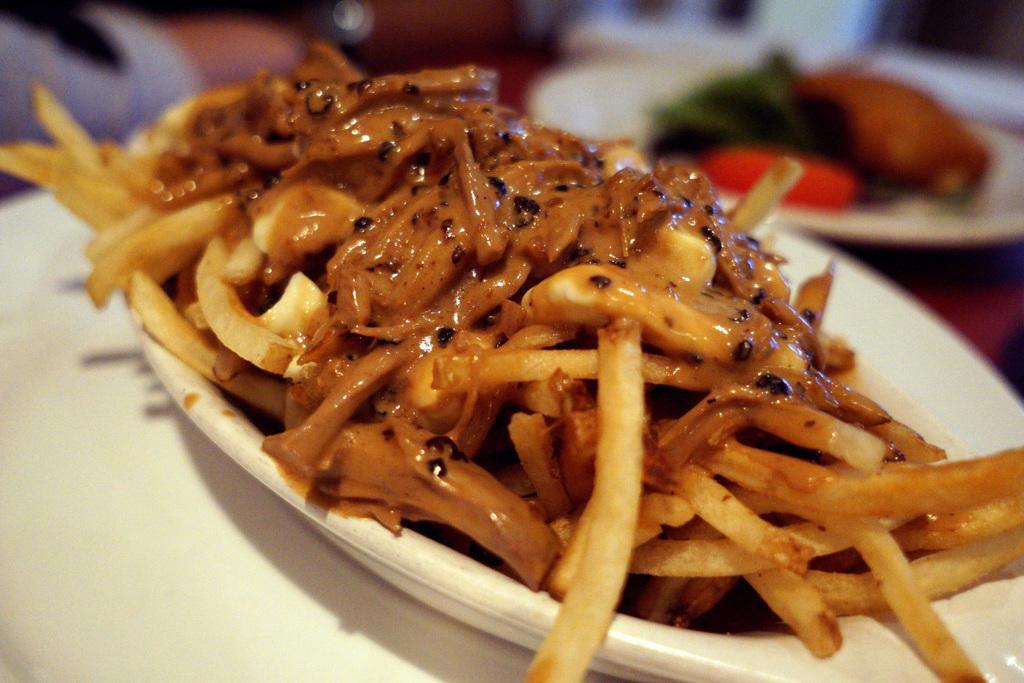Describe this image in one or two sentences. In this image there is some food item is kept in a white color bowl in middle of this image and there is one another bowl is on top right corner of this image and there is some object is in white color on the bottom left corner of this image. 